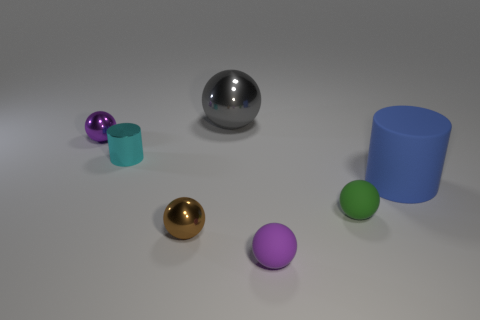What number of gray things are made of the same material as the big sphere?
Provide a succinct answer. 0. What is the color of the cylinder that is made of the same material as the tiny green sphere?
Provide a succinct answer. Blue. What is the purple sphere right of the tiny shiny ball in front of the small purple sphere that is behind the blue matte cylinder made of?
Give a very brief answer. Rubber. Does the thing that is in front of the brown sphere have the same size as the gray metallic thing?
Provide a succinct answer. No. What number of tiny objects are metallic things or brown rubber things?
Give a very brief answer. 3. Are there any things of the same color as the metal cylinder?
Give a very brief answer. No. What shape is the green object that is the same size as the brown shiny ball?
Provide a succinct answer. Sphere. There is a cylinder that is in front of the cyan thing; is its color the same as the large metallic object?
Make the answer very short. No. How many things are small metallic objects that are behind the tiny brown metal thing or large purple metal balls?
Keep it short and to the point. 2. Are there more small green objects that are behind the big gray shiny sphere than small metal balls that are in front of the cyan metallic thing?
Offer a very short reply. No. 